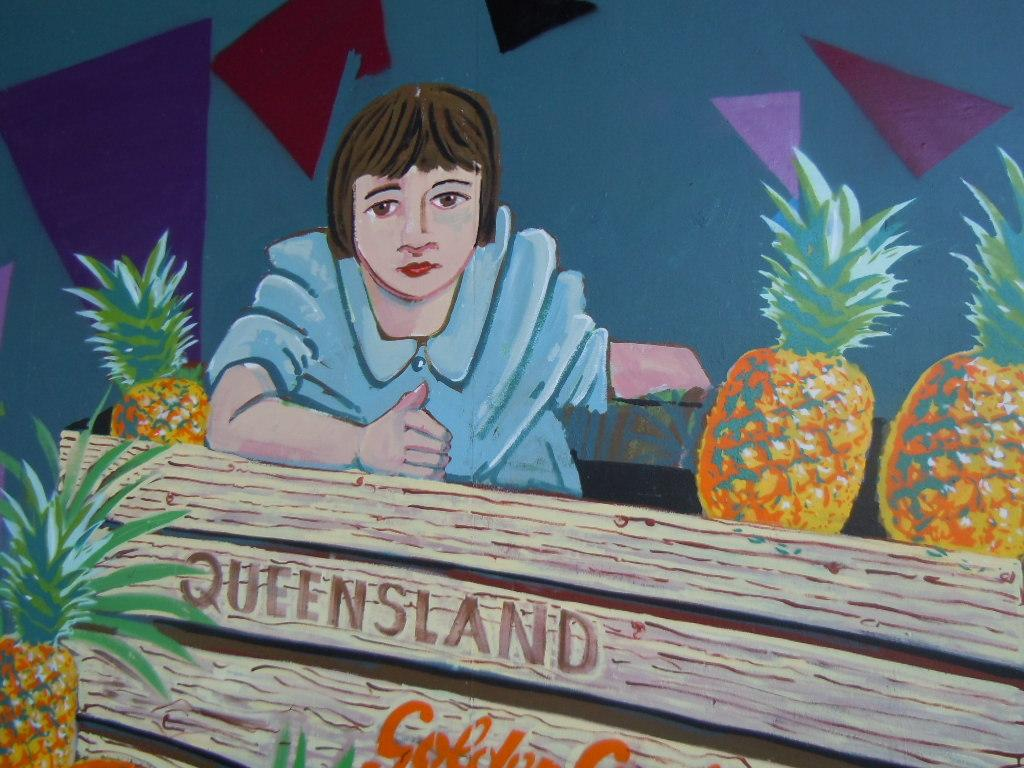What is depicted in the painting in the image? There is a painting of a woman in the image. What type of fruit can be seen in the image? There are pineapples in the image. What can be seen on the backside of the image? There is a wall visible on the backside of the image. What type of shirt is the porter wearing in the image? There is no porter present in the image, so it is not possible to determine what type of shirt they might be wearing. 